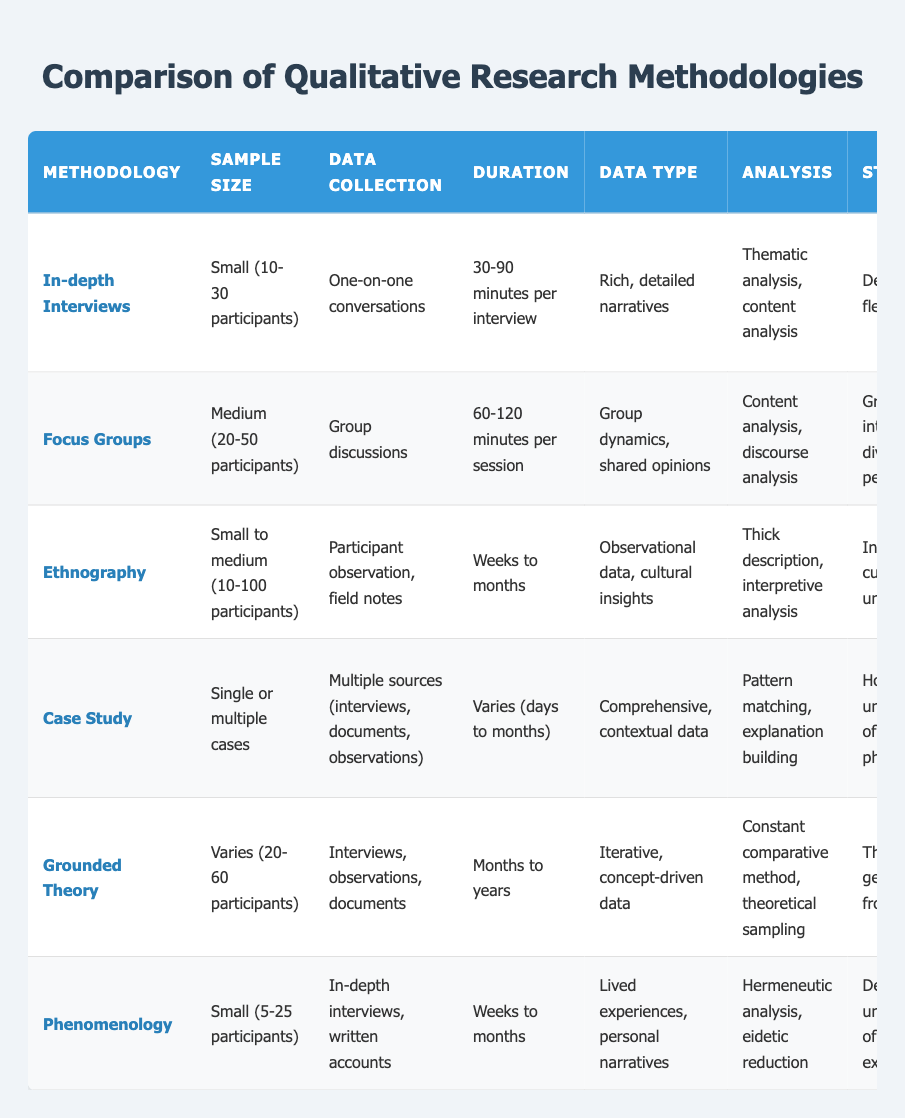What is the sample size range for ethnography? Ethnography has a sample size range of small to medium, specifically 10 to 100 participants, as stated in the table.
Answer: Small to medium (10-100 participants) Which methodology has the longest duration for data collection? The longest duration for data collection in the table is under ethnography, which takes weeks to months. No other methodology has a longer time period listed for data collection.
Answer: Ethnography Is it true that focus groups focus on individual experiences? No, it is not true. Focus groups aim to explore collective opinions and social norms, rather than individual experiences as indicated in the "best for" section of the table.
Answer: No What are the weaknesses of grounded theory? Grounded theory has two listed weaknesses: it is time-consuming and requires theoretical sensitivity, as outlined in the table.
Answer: Time-consuming, requires theoretical sensitivity Which methodology is best for understanding individual experiences and perspectives? According to the table, in-depth interviews are best for understanding individual experiences and perspectives, as clearly noted in the "best for" column.
Answer: In-depth interviews What is the average sample size for the methodologies listed? To find the average sample size, we consider different ranges: In-depth interviews (20), focus groups (35), ethnography (55), case study is variable, grounded theory (40), and phenomenology (15). Calculating this gives: (20 + 35 + 55 + 1 (case study variable) + 40 + 15) / 5 = 33.7, without case study this averages slightly lower as we can’t include it.
Answer: Approximately 33.7 Which methodology emphasizes theory generation from data? Grounded theory is the methodology that places emphasis on theory generation, as specified in the strengths section of the table.
Answer: Grounded theory Is it true that dominant personalities may influence other participants in focus groups? Yes, this statement is true as the table indicates it is a weakness of focus groups, suggesting that group dynamics may lead to some voices overpowering others.
Answer: Yes How many methodologies have a small sample size category? Four methodologies—In-depth interviews, ethnography, phenomenology, and focus groups fall into a small sample size category while grounded theory and case study vary. Thus, there are four methodologies that specifically indicate small sample sizes in their description.
Answer: Four 